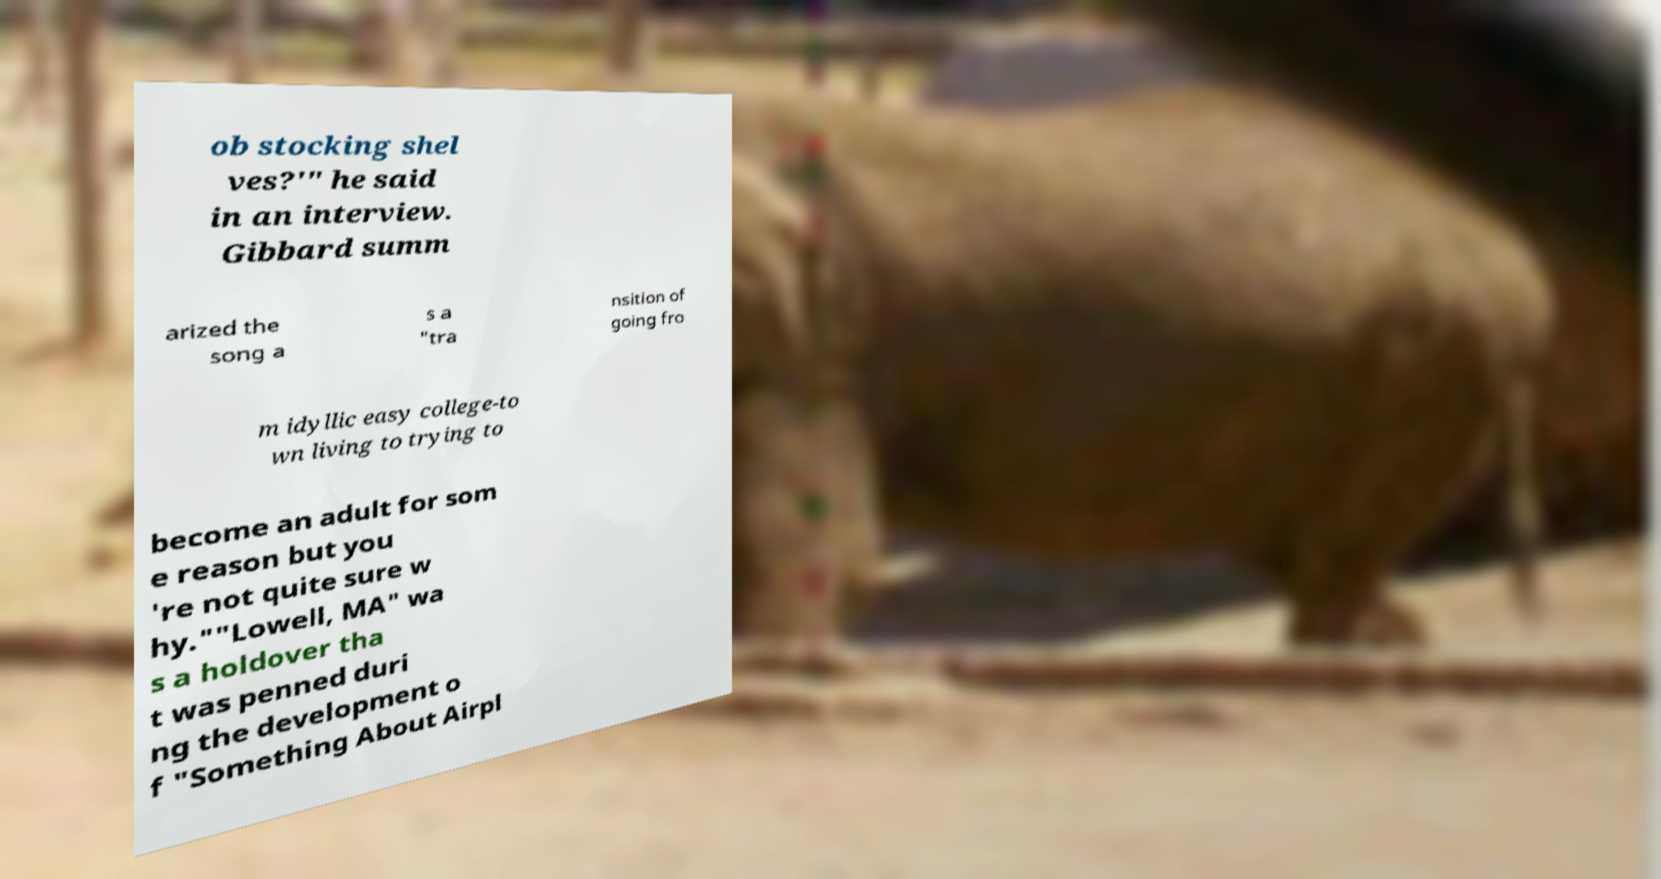For documentation purposes, I need the text within this image transcribed. Could you provide that? ob stocking shel ves?'" he said in an interview. Gibbard summ arized the song a s a "tra nsition of going fro m idyllic easy college-to wn living to trying to become an adult for som e reason but you 're not quite sure w hy.""Lowell, MA" wa s a holdover tha t was penned duri ng the development o f "Something About Airpl 